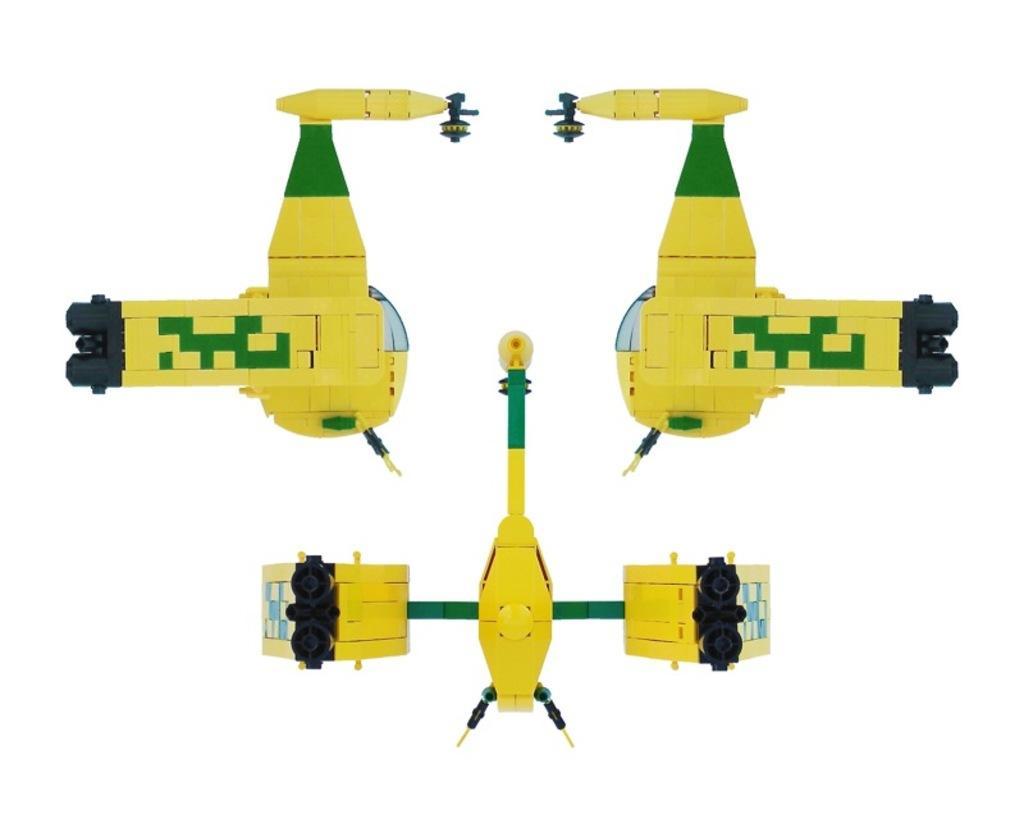Could you give a brief overview of what you see in this image? In this image I can see few toys made up of building blocks. The background is white in color. 